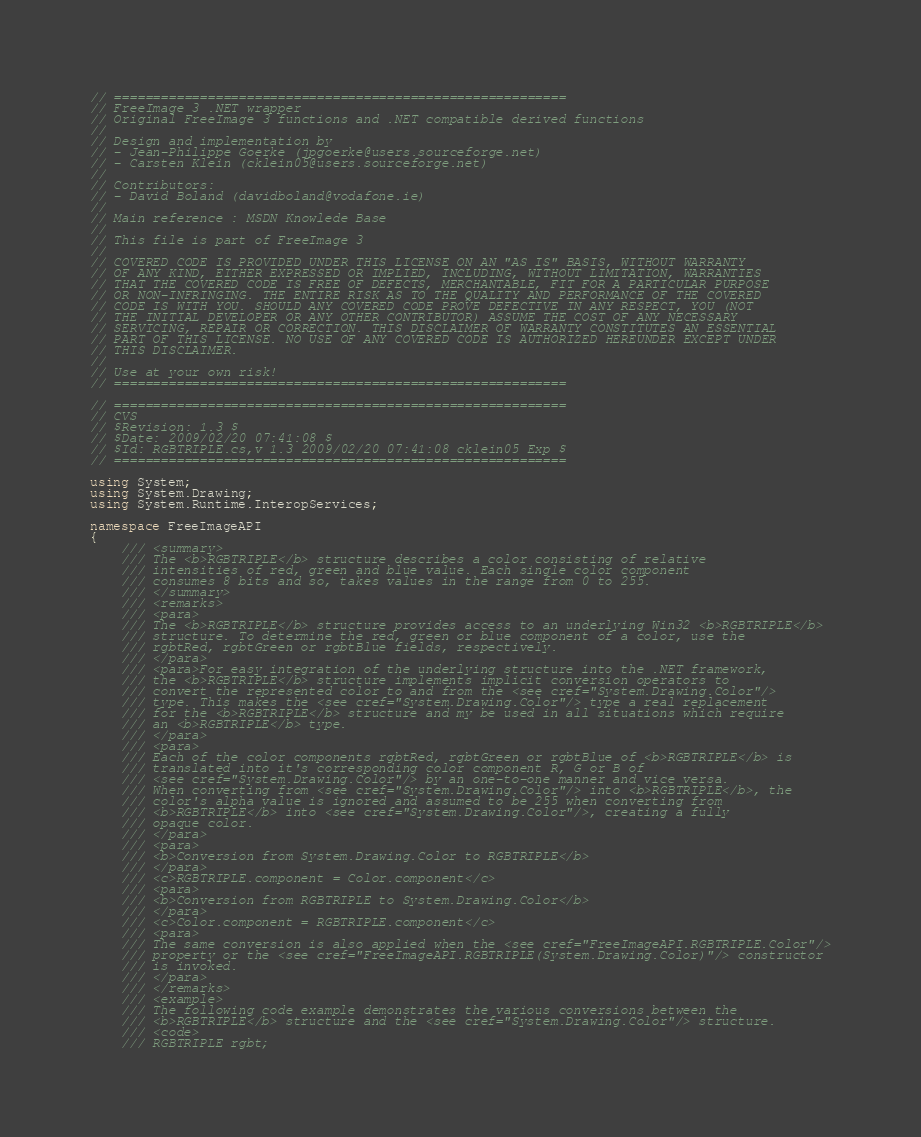Convert code to text. <code><loc_0><loc_0><loc_500><loc_500><_C#_>// ==========================================================
// FreeImage 3 .NET wrapper
// Original FreeImage 3 functions and .NET compatible derived functions
//
// Design and implementation by
// - Jean-Philippe Goerke (jpgoerke@users.sourceforge.net)
// - Carsten Klein (cklein05@users.sourceforge.net)
//
// Contributors:
// - David Boland (davidboland@vodafone.ie)
//
// Main reference : MSDN Knowlede Base
//
// This file is part of FreeImage 3
//
// COVERED CODE IS PROVIDED UNDER THIS LICENSE ON AN "AS IS" BASIS, WITHOUT WARRANTY
// OF ANY KIND, EITHER EXPRESSED OR IMPLIED, INCLUDING, WITHOUT LIMITATION, WARRANTIES
// THAT THE COVERED CODE IS FREE OF DEFECTS, MERCHANTABLE, FIT FOR A PARTICULAR PURPOSE
// OR NON-INFRINGING. THE ENTIRE RISK AS TO THE QUALITY AND PERFORMANCE OF THE COVERED
// CODE IS WITH YOU. SHOULD ANY COVERED CODE PROVE DEFECTIVE IN ANY RESPECT, YOU (NOT
// THE INITIAL DEVELOPER OR ANY OTHER CONTRIBUTOR) ASSUME THE COST OF ANY NECESSARY
// SERVICING, REPAIR OR CORRECTION. THIS DISCLAIMER OF WARRANTY CONSTITUTES AN ESSENTIAL
// PART OF THIS LICENSE. NO USE OF ANY COVERED CODE IS AUTHORIZED HEREUNDER EXCEPT UNDER
// THIS DISCLAIMER.
//
// Use at your own risk!
// ==========================================================

// ==========================================================
// CVS
// $Revision: 1.3 $
// $Date: 2009/02/20 07:41:08 $
// $Id: RGBTRIPLE.cs,v 1.3 2009/02/20 07:41:08 cklein05 Exp $
// ==========================================================

using System;
using System.Drawing;
using System.Runtime.InteropServices;

namespace FreeImageAPI
{
	/// <summary>
	/// The <b>RGBTRIPLE</b> structure describes a color consisting of relative
	/// intensities of red, green and blue value. Each single color component
	/// consumes 8 bits and so, takes values in the range from 0 to 255.
	/// </summary>
	/// <remarks>
	/// <para>
	/// The <b>RGBTRIPLE</b> structure provides access to an underlying Win32 <b>RGBTRIPLE</b>
	/// structure. To determine the red, green or blue component of a color, use the
	/// rgbtRed, rgbtGreen or rgbtBlue fields, respectively.
	/// </para>
	/// <para>For easy integration of the underlying structure into the .NET framework,
	/// the <b>RGBTRIPLE</b> structure implements implicit conversion operators to 
	/// convert the represented color to and from the <see cref="System.Drawing.Color"/>
	/// type. This makes the <see cref="System.Drawing.Color"/> type a real replacement
	/// for the <b>RGBTRIPLE</b> structure and my be used in all situations which require
	/// an <b>RGBTRIPLE</b> type.
	/// </para>
	/// <para>
	/// Each of the color components rgbtRed, rgbtGreen or rgbtBlue of <b>RGBTRIPLE</b> is
	/// translated into it's corresponding color component R, G or B of
	/// <see cref="System.Drawing.Color"/> by an one-to-one manner and vice versa.
	/// When converting from <see cref="System.Drawing.Color"/> into <b>RGBTRIPLE</b>, the
	/// color's alpha value is ignored and assumed to be 255 when converting from
	/// <b>RGBTRIPLE</b> into <see cref="System.Drawing.Color"/>, creating a fully
	/// opaque color.
	/// </para>
	/// <para>
	/// <b>Conversion from System.Drawing.Color to RGBTRIPLE</b>
	/// </para>
	/// <c>RGBTRIPLE.component = Color.component</c>
	/// <para>
	/// <b>Conversion from RGBTRIPLE to System.Drawing.Color</b>
	/// </para>
	/// <c>Color.component = RGBTRIPLE.component</c>
	/// <para>
	/// The same conversion is also applied when the <see cref="FreeImageAPI.RGBTRIPLE.Color"/>
	/// property or the <see cref="FreeImageAPI.RGBTRIPLE(System.Drawing.Color)"/> constructor
	/// is invoked.
	/// </para>
	/// </remarks>
	/// <example>
	/// The following code example demonstrates the various conversions between the
	/// <b>RGBTRIPLE</b> structure and the <see cref="System.Drawing.Color"/> structure.
	/// <code>
	/// RGBTRIPLE rgbt;</code> 